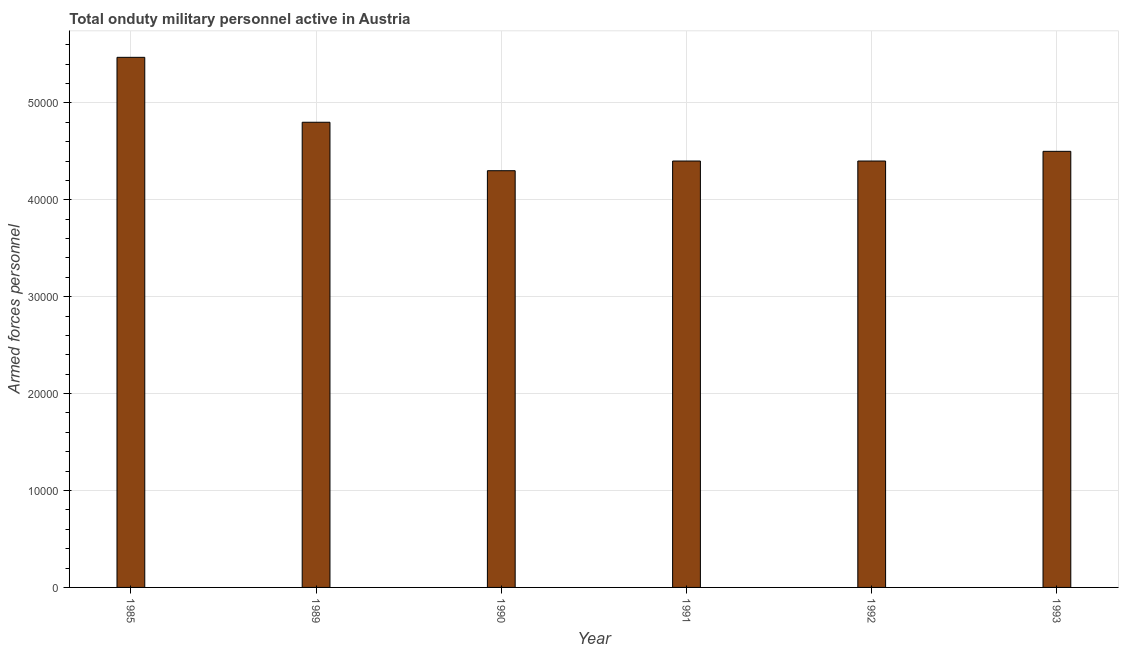Does the graph contain any zero values?
Your answer should be compact. No. Does the graph contain grids?
Make the answer very short. Yes. What is the title of the graph?
Make the answer very short. Total onduty military personnel active in Austria. What is the label or title of the Y-axis?
Provide a short and direct response. Armed forces personnel. What is the number of armed forces personnel in 1990?
Your response must be concise. 4.30e+04. Across all years, what is the maximum number of armed forces personnel?
Provide a short and direct response. 5.47e+04. Across all years, what is the minimum number of armed forces personnel?
Ensure brevity in your answer.  4.30e+04. In which year was the number of armed forces personnel maximum?
Provide a succinct answer. 1985. What is the sum of the number of armed forces personnel?
Your response must be concise. 2.79e+05. What is the difference between the number of armed forces personnel in 1985 and 1989?
Your answer should be very brief. 6700. What is the average number of armed forces personnel per year?
Make the answer very short. 4.64e+04. What is the median number of armed forces personnel?
Offer a very short reply. 4.45e+04. In how many years, is the number of armed forces personnel greater than 18000 ?
Provide a succinct answer. 6. Do a majority of the years between 1992 and 1989 (inclusive) have number of armed forces personnel greater than 2000 ?
Offer a terse response. Yes. What is the ratio of the number of armed forces personnel in 1989 to that in 1992?
Provide a succinct answer. 1.09. Is the difference between the number of armed forces personnel in 1985 and 1990 greater than the difference between any two years?
Offer a terse response. Yes. What is the difference between the highest and the second highest number of armed forces personnel?
Ensure brevity in your answer.  6700. What is the difference between the highest and the lowest number of armed forces personnel?
Your response must be concise. 1.17e+04. How many bars are there?
Offer a very short reply. 6. Are all the bars in the graph horizontal?
Your response must be concise. No. How many years are there in the graph?
Give a very brief answer. 6. What is the Armed forces personnel of 1985?
Your response must be concise. 5.47e+04. What is the Armed forces personnel in 1989?
Offer a terse response. 4.80e+04. What is the Armed forces personnel of 1990?
Your response must be concise. 4.30e+04. What is the Armed forces personnel in 1991?
Offer a very short reply. 4.40e+04. What is the Armed forces personnel in 1992?
Offer a very short reply. 4.40e+04. What is the Armed forces personnel of 1993?
Your answer should be compact. 4.50e+04. What is the difference between the Armed forces personnel in 1985 and 1989?
Offer a very short reply. 6700. What is the difference between the Armed forces personnel in 1985 and 1990?
Ensure brevity in your answer.  1.17e+04. What is the difference between the Armed forces personnel in 1985 and 1991?
Your answer should be very brief. 1.07e+04. What is the difference between the Armed forces personnel in 1985 and 1992?
Keep it short and to the point. 1.07e+04. What is the difference between the Armed forces personnel in 1985 and 1993?
Your answer should be very brief. 9700. What is the difference between the Armed forces personnel in 1989 and 1990?
Offer a very short reply. 5000. What is the difference between the Armed forces personnel in 1989 and 1991?
Ensure brevity in your answer.  4000. What is the difference between the Armed forces personnel in 1989 and 1992?
Give a very brief answer. 4000. What is the difference between the Armed forces personnel in 1989 and 1993?
Offer a terse response. 3000. What is the difference between the Armed forces personnel in 1990 and 1991?
Your answer should be compact. -1000. What is the difference between the Armed forces personnel in 1990 and 1992?
Provide a succinct answer. -1000. What is the difference between the Armed forces personnel in 1990 and 1993?
Make the answer very short. -2000. What is the difference between the Armed forces personnel in 1991 and 1992?
Keep it short and to the point. 0. What is the difference between the Armed forces personnel in 1991 and 1993?
Ensure brevity in your answer.  -1000. What is the difference between the Armed forces personnel in 1992 and 1993?
Offer a terse response. -1000. What is the ratio of the Armed forces personnel in 1985 to that in 1989?
Ensure brevity in your answer.  1.14. What is the ratio of the Armed forces personnel in 1985 to that in 1990?
Keep it short and to the point. 1.27. What is the ratio of the Armed forces personnel in 1985 to that in 1991?
Offer a very short reply. 1.24. What is the ratio of the Armed forces personnel in 1985 to that in 1992?
Ensure brevity in your answer.  1.24. What is the ratio of the Armed forces personnel in 1985 to that in 1993?
Offer a very short reply. 1.22. What is the ratio of the Armed forces personnel in 1989 to that in 1990?
Offer a very short reply. 1.12. What is the ratio of the Armed forces personnel in 1989 to that in 1991?
Offer a very short reply. 1.09. What is the ratio of the Armed forces personnel in 1989 to that in 1992?
Offer a terse response. 1.09. What is the ratio of the Armed forces personnel in 1989 to that in 1993?
Ensure brevity in your answer.  1.07. What is the ratio of the Armed forces personnel in 1990 to that in 1991?
Provide a short and direct response. 0.98. What is the ratio of the Armed forces personnel in 1990 to that in 1993?
Keep it short and to the point. 0.96. What is the ratio of the Armed forces personnel in 1992 to that in 1993?
Keep it short and to the point. 0.98. 